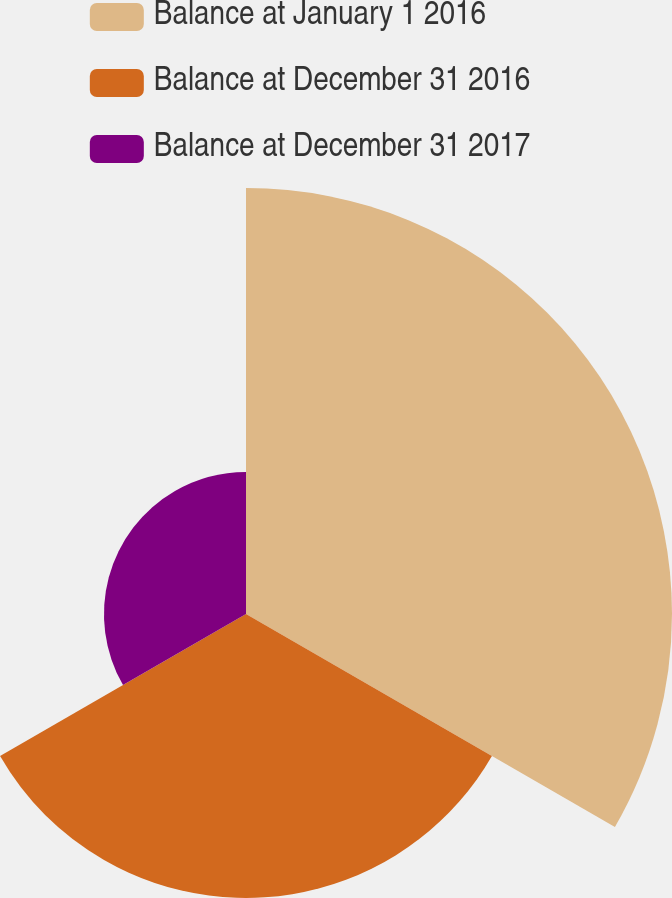Convert chart to OTSL. <chart><loc_0><loc_0><loc_500><loc_500><pie_chart><fcel>Balance at January 1 2016<fcel>Balance at December 31 2016<fcel>Balance at December 31 2017<nl><fcel>50.0%<fcel>33.33%<fcel>16.67%<nl></chart> 